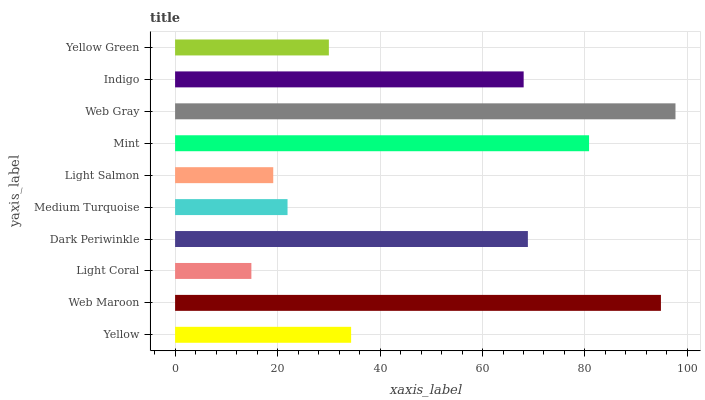Is Light Coral the minimum?
Answer yes or no. Yes. Is Web Gray the maximum?
Answer yes or no. Yes. Is Web Maroon the minimum?
Answer yes or no. No. Is Web Maroon the maximum?
Answer yes or no. No. Is Web Maroon greater than Yellow?
Answer yes or no. Yes. Is Yellow less than Web Maroon?
Answer yes or no. Yes. Is Yellow greater than Web Maroon?
Answer yes or no. No. Is Web Maroon less than Yellow?
Answer yes or no. No. Is Indigo the high median?
Answer yes or no. Yes. Is Yellow the low median?
Answer yes or no. Yes. Is Medium Turquoise the high median?
Answer yes or no. No. Is Mint the low median?
Answer yes or no. No. 